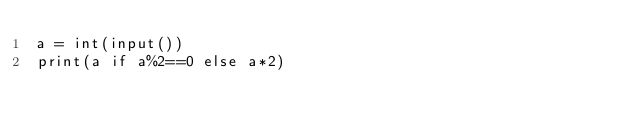<code> <loc_0><loc_0><loc_500><loc_500><_Python_>a = int(input())
print(a if a%2==0 else a*2)</code> 